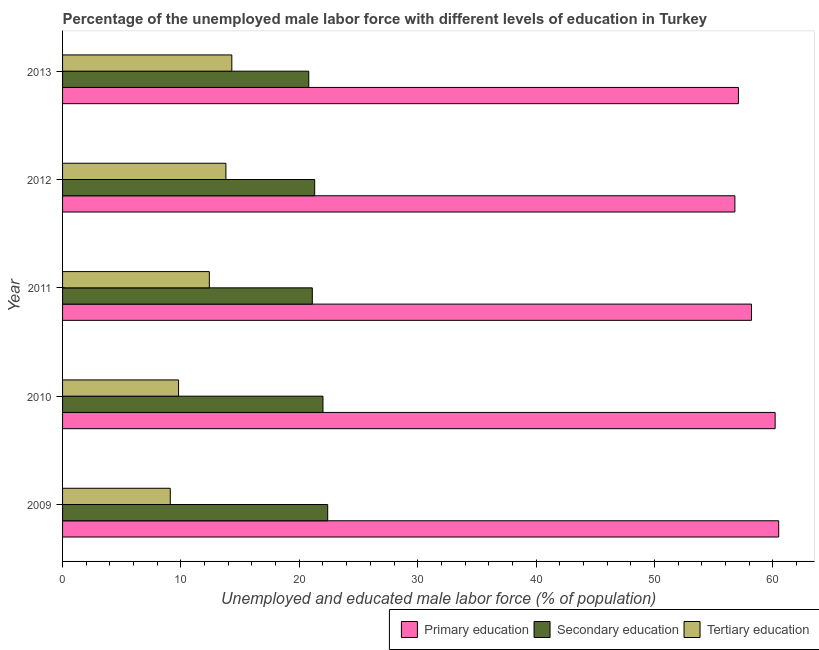Are the number of bars per tick equal to the number of legend labels?
Your response must be concise. Yes. How many bars are there on the 1st tick from the top?
Keep it short and to the point. 3. What is the percentage of male labor force who received tertiary education in 2011?
Provide a short and direct response. 12.4. Across all years, what is the maximum percentage of male labor force who received primary education?
Offer a very short reply. 60.5. Across all years, what is the minimum percentage of male labor force who received tertiary education?
Offer a terse response. 9.1. In which year was the percentage of male labor force who received tertiary education maximum?
Your answer should be compact. 2013. What is the total percentage of male labor force who received secondary education in the graph?
Offer a terse response. 107.6. What is the difference between the percentage of male labor force who received tertiary education in 2012 and the percentage of male labor force who received primary education in 2013?
Ensure brevity in your answer.  -43.3. What is the average percentage of male labor force who received secondary education per year?
Your answer should be compact. 21.52. In the year 2012, what is the difference between the percentage of male labor force who received secondary education and percentage of male labor force who received primary education?
Ensure brevity in your answer.  -35.5. In how many years, is the percentage of male labor force who received primary education greater than 2 %?
Make the answer very short. 5. What is the difference between the highest and the lowest percentage of male labor force who received secondary education?
Your answer should be compact. 1.6. In how many years, is the percentage of male labor force who received secondary education greater than the average percentage of male labor force who received secondary education taken over all years?
Keep it short and to the point. 2. What does the 3rd bar from the bottom in 2011 represents?
Your answer should be compact. Tertiary education. How many bars are there?
Your response must be concise. 15. How many years are there in the graph?
Your answer should be very brief. 5. What is the difference between two consecutive major ticks on the X-axis?
Make the answer very short. 10. Does the graph contain any zero values?
Your answer should be compact. No. Where does the legend appear in the graph?
Offer a very short reply. Bottom right. How are the legend labels stacked?
Your response must be concise. Horizontal. What is the title of the graph?
Make the answer very short. Percentage of the unemployed male labor force with different levels of education in Turkey. Does "Argument" appear as one of the legend labels in the graph?
Your response must be concise. No. What is the label or title of the X-axis?
Offer a very short reply. Unemployed and educated male labor force (% of population). What is the label or title of the Y-axis?
Offer a terse response. Year. What is the Unemployed and educated male labor force (% of population) in Primary education in 2009?
Provide a succinct answer. 60.5. What is the Unemployed and educated male labor force (% of population) of Secondary education in 2009?
Provide a short and direct response. 22.4. What is the Unemployed and educated male labor force (% of population) of Tertiary education in 2009?
Give a very brief answer. 9.1. What is the Unemployed and educated male labor force (% of population) in Primary education in 2010?
Your answer should be very brief. 60.2. What is the Unemployed and educated male labor force (% of population) in Tertiary education in 2010?
Your response must be concise. 9.8. What is the Unemployed and educated male labor force (% of population) of Primary education in 2011?
Your answer should be very brief. 58.2. What is the Unemployed and educated male labor force (% of population) in Secondary education in 2011?
Your answer should be compact. 21.1. What is the Unemployed and educated male labor force (% of population) in Tertiary education in 2011?
Offer a very short reply. 12.4. What is the Unemployed and educated male labor force (% of population) in Primary education in 2012?
Ensure brevity in your answer.  56.8. What is the Unemployed and educated male labor force (% of population) in Secondary education in 2012?
Your response must be concise. 21.3. What is the Unemployed and educated male labor force (% of population) in Tertiary education in 2012?
Keep it short and to the point. 13.8. What is the Unemployed and educated male labor force (% of population) in Primary education in 2013?
Your response must be concise. 57.1. What is the Unemployed and educated male labor force (% of population) in Secondary education in 2013?
Your response must be concise. 20.8. What is the Unemployed and educated male labor force (% of population) in Tertiary education in 2013?
Keep it short and to the point. 14.3. Across all years, what is the maximum Unemployed and educated male labor force (% of population) in Primary education?
Your answer should be compact. 60.5. Across all years, what is the maximum Unemployed and educated male labor force (% of population) in Secondary education?
Give a very brief answer. 22.4. Across all years, what is the maximum Unemployed and educated male labor force (% of population) in Tertiary education?
Your response must be concise. 14.3. Across all years, what is the minimum Unemployed and educated male labor force (% of population) in Primary education?
Give a very brief answer. 56.8. Across all years, what is the minimum Unemployed and educated male labor force (% of population) of Secondary education?
Give a very brief answer. 20.8. Across all years, what is the minimum Unemployed and educated male labor force (% of population) of Tertiary education?
Keep it short and to the point. 9.1. What is the total Unemployed and educated male labor force (% of population) of Primary education in the graph?
Your answer should be very brief. 292.8. What is the total Unemployed and educated male labor force (% of population) of Secondary education in the graph?
Give a very brief answer. 107.6. What is the total Unemployed and educated male labor force (% of population) in Tertiary education in the graph?
Your response must be concise. 59.4. What is the difference between the Unemployed and educated male labor force (% of population) of Primary education in 2009 and that in 2010?
Offer a very short reply. 0.3. What is the difference between the Unemployed and educated male labor force (% of population) of Secondary education in 2009 and that in 2010?
Provide a short and direct response. 0.4. What is the difference between the Unemployed and educated male labor force (% of population) in Primary education in 2009 and that in 2011?
Ensure brevity in your answer.  2.3. What is the difference between the Unemployed and educated male labor force (% of population) in Secondary education in 2009 and that in 2012?
Provide a succinct answer. 1.1. What is the difference between the Unemployed and educated male labor force (% of population) in Primary education in 2009 and that in 2013?
Provide a succinct answer. 3.4. What is the difference between the Unemployed and educated male labor force (% of population) in Secondary education in 2009 and that in 2013?
Make the answer very short. 1.6. What is the difference between the Unemployed and educated male labor force (% of population) of Tertiary education in 2009 and that in 2013?
Offer a terse response. -5.2. What is the difference between the Unemployed and educated male labor force (% of population) in Primary education in 2010 and that in 2011?
Keep it short and to the point. 2. What is the difference between the Unemployed and educated male labor force (% of population) in Secondary education in 2010 and that in 2011?
Provide a succinct answer. 0.9. What is the difference between the Unemployed and educated male labor force (% of population) of Primary education in 2010 and that in 2012?
Provide a short and direct response. 3.4. What is the difference between the Unemployed and educated male labor force (% of population) of Secondary education in 2010 and that in 2012?
Make the answer very short. 0.7. What is the difference between the Unemployed and educated male labor force (% of population) in Tertiary education in 2010 and that in 2012?
Keep it short and to the point. -4. What is the difference between the Unemployed and educated male labor force (% of population) of Secondary education in 2010 and that in 2013?
Provide a short and direct response. 1.2. What is the difference between the Unemployed and educated male labor force (% of population) of Tertiary education in 2010 and that in 2013?
Make the answer very short. -4.5. What is the difference between the Unemployed and educated male labor force (% of population) of Primary education in 2011 and that in 2012?
Keep it short and to the point. 1.4. What is the difference between the Unemployed and educated male labor force (% of population) in Secondary education in 2011 and that in 2012?
Your answer should be very brief. -0.2. What is the difference between the Unemployed and educated male labor force (% of population) in Primary education in 2011 and that in 2013?
Ensure brevity in your answer.  1.1. What is the difference between the Unemployed and educated male labor force (% of population) of Secondary education in 2011 and that in 2013?
Ensure brevity in your answer.  0.3. What is the difference between the Unemployed and educated male labor force (% of population) of Primary education in 2012 and that in 2013?
Offer a very short reply. -0.3. What is the difference between the Unemployed and educated male labor force (% of population) of Secondary education in 2012 and that in 2013?
Your response must be concise. 0.5. What is the difference between the Unemployed and educated male labor force (% of population) in Tertiary education in 2012 and that in 2013?
Give a very brief answer. -0.5. What is the difference between the Unemployed and educated male labor force (% of population) of Primary education in 2009 and the Unemployed and educated male labor force (% of population) of Secondary education in 2010?
Provide a succinct answer. 38.5. What is the difference between the Unemployed and educated male labor force (% of population) of Primary education in 2009 and the Unemployed and educated male labor force (% of population) of Tertiary education in 2010?
Keep it short and to the point. 50.7. What is the difference between the Unemployed and educated male labor force (% of population) of Secondary education in 2009 and the Unemployed and educated male labor force (% of population) of Tertiary education in 2010?
Offer a terse response. 12.6. What is the difference between the Unemployed and educated male labor force (% of population) in Primary education in 2009 and the Unemployed and educated male labor force (% of population) in Secondary education in 2011?
Your answer should be very brief. 39.4. What is the difference between the Unemployed and educated male labor force (% of population) of Primary education in 2009 and the Unemployed and educated male labor force (% of population) of Tertiary education in 2011?
Provide a short and direct response. 48.1. What is the difference between the Unemployed and educated male labor force (% of population) in Secondary education in 2009 and the Unemployed and educated male labor force (% of population) in Tertiary education in 2011?
Make the answer very short. 10. What is the difference between the Unemployed and educated male labor force (% of population) in Primary education in 2009 and the Unemployed and educated male labor force (% of population) in Secondary education in 2012?
Make the answer very short. 39.2. What is the difference between the Unemployed and educated male labor force (% of population) in Primary education in 2009 and the Unemployed and educated male labor force (% of population) in Tertiary education in 2012?
Your answer should be compact. 46.7. What is the difference between the Unemployed and educated male labor force (% of population) in Primary education in 2009 and the Unemployed and educated male labor force (% of population) in Secondary education in 2013?
Your response must be concise. 39.7. What is the difference between the Unemployed and educated male labor force (% of population) of Primary education in 2009 and the Unemployed and educated male labor force (% of population) of Tertiary education in 2013?
Your answer should be very brief. 46.2. What is the difference between the Unemployed and educated male labor force (% of population) of Secondary education in 2009 and the Unemployed and educated male labor force (% of population) of Tertiary education in 2013?
Your response must be concise. 8.1. What is the difference between the Unemployed and educated male labor force (% of population) of Primary education in 2010 and the Unemployed and educated male labor force (% of population) of Secondary education in 2011?
Your answer should be very brief. 39.1. What is the difference between the Unemployed and educated male labor force (% of population) in Primary education in 2010 and the Unemployed and educated male labor force (% of population) in Tertiary education in 2011?
Offer a terse response. 47.8. What is the difference between the Unemployed and educated male labor force (% of population) of Secondary education in 2010 and the Unemployed and educated male labor force (% of population) of Tertiary education in 2011?
Offer a terse response. 9.6. What is the difference between the Unemployed and educated male labor force (% of population) in Primary education in 2010 and the Unemployed and educated male labor force (% of population) in Secondary education in 2012?
Ensure brevity in your answer.  38.9. What is the difference between the Unemployed and educated male labor force (% of population) of Primary education in 2010 and the Unemployed and educated male labor force (% of population) of Tertiary education in 2012?
Your answer should be compact. 46.4. What is the difference between the Unemployed and educated male labor force (% of population) in Secondary education in 2010 and the Unemployed and educated male labor force (% of population) in Tertiary education in 2012?
Make the answer very short. 8.2. What is the difference between the Unemployed and educated male labor force (% of population) in Primary education in 2010 and the Unemployed and educated male labor force (% of population) in Secondary education in 2013?
Ensure brevity in your answer.  39.4. What is the difference between the Unemployed and educated male labor force (% of population) in Primary education in 2010 and the Unemployed and educated male labor force (% of population) in Tertiary education in 2013?
Ensure brevity in your answer.  45.9. What is the difference between the Unemployed and educated male labor force (% of population) in Secondary education in 2010 and the Unemployed and educated male labor force (% of population) in Tertiary education in 2013?
Give a very brief answer. 7.7. What is the difference between the Unemployed and educated male labor force (% of population) of Primary education in 2011 and the Unemployed and educated male labor force (% of population) of Secondary education in 2012?
Offer a terse response. 36.9. What is the difference between the Unemployed and educated male labor force (% of population) in Primary education in 2011 and the Unemployed and educated male labor force (% of population) in Tertiary education in 2012?
Provide a short and direct response. 44.4. What is the difference between the Unemployed and educated male labor force (% of population) of Secondary education in 2011 and the Unemployed and educated male labor force (% of population) of Tertiary education in 2012?
Give a very brief answer. 7.3. What is the difference between the Unemployed and educated male labor force (% of population) of Primary education in 2011 and the Unemployed and educated male labor force (% of population) of Secondary education in 2013?
Give a very brief answer. 37.4. What is the difference between the Unemployed and educated male labor force (% of population) of Primary education in 2011 and the Unemployed and educated male labor force (% of population) of Tertiary education in 2013?
Offer a terse response. 43.9. What is the difference between the Unemployed and educated male labor force (% of population) of Secondary education in 2011 and the Unemployed and educated male labor force (% of population) of Tertiary education in 2013?
Ensure brevity in your answer.  6.8. What is the difference between the Unemployed and educated male labor force (% of population) of Primary education in 2012 and the Unemployed and educated male labor force (% of population) of Tertiary education in 2013?
Offer a very short reply. 42.5. What is the difference between the Unemployed and educated male labor force (% of population) in Secondary education in 2012 and the Unemployed and educated male labor force (% of population) in Tertiary education in 2013?
Offer a terse response. 7. What is the average Unemployed and educated male labor force (% of population) of Primary education per year?
Make the answer very short. 58.56. What is the average Unemployed and educated male labor force (% of population) of Secondary education per year?
Give a very brief answer. 21.52. What is the average Unemployed and educated male labor force (% of population) in Tertiary education per year?
Provide a short and direct response. 11.88. In the year 2009, what is the difference between the Unemployed and educated male labor force (% of population) of Primary education and Unemployed and educated male labor force (% of population) of Secondary education?
Ensure brevity in your answer.  38.1. In the year 2009, what is the difference between the Unemployed and educated male labor force (% of population) of Primary education and Unemployed and educated male labor force (% of population) of Tertiary education?
Provide a succinct answer. 51.4. In the year 2009, what is the difference between the Unemployed and educated male labor force (% of population) of Secondary education and Unemployed and educated male labor force (% of population) of Tertiary education?
Your response must be concise. 13.3. In the year 2010, what is the difference between the Unemployed and educated male labor force (% of population) of Primary education and Unemployed and educated male labor force (% of population) of Secondary education?
Your response must be concise. 38.2. In the year 2010, what is the difference between the Unemployed and educated male labor force (% of population) in Primary education and Unemployed and educated male labor force (% of population) in Tertiary education?
Provide a succinct answer. 50.4. In the year 2010, what is the difference between the Unemployed and educated male labor force (% of population) in Secondary education and Unemployed and educated male labor force (% of population) in Tertiary education?
Provide a short and direct response. 12.2. In the year 2011, what is the difference between the Unemployed and educated male labor force (% of population) in Primary education and Unemployed and educated male labor force (% of population) in Secondary education?
Provide a succinct answer. 37.1. In the year 2011, what is the difference between the Unemployed and educated male labor force (% of population) of Primary education and Unemployed and educated male labor force (% of population) of Tertiary education?
Your answer should be very brief. 45.8. In the year 2011, what is the difference between the Unemployed and educated male labor force (% of population) of Secondary education and Unemployed and educated male labor force (% of population) of Tertiary education?
Your answer should be very brief. 8.7. In the year 2012, what is the difference between the Unemployed and educated male labor force (% of population) in Primary education and Unemployed and educated male labor force (% of population) in Secondary education?
Make the answer very short. 35.5. In the year 2012, what is the difference between the Unemployed and educated male labor force (% of population) in Secondary education and Unemployed and educated male labor force (% of population) in Tertiary education?
Make the answer very short. 7.5. In the year 2013, what is the difference between the Unemployed and educated male labor force (% of population) in Primary education and Unemployed and educated male labor force (% of population) in Secondary education?
Ensure brevity in your answer.  36.3. In the year 2013, what is the difference between the Unemployed and educated male labor force (% of population) of Primary education and Unemployed and educated male labor force (% of population) of Tertiary education?
Offer a terse response. 42.8. In the year 2013, what is the difference between the Unemployed and educated male labor force (% of population) of Secondary education and Unemployed and educated male labor force (% of population) of Tertiary education?
Offer a terse response. 6.5. What is the ratio of the Unemployed and educated male labor force (% of population) in Primary education in 2009 to that in 2010?
Offer a very short reply. 1. What is the ratio of the Unemployed and educated male labor force (% of population) in Secondary education in 2009 to that in 2010?
Offer a terse response. 1.02. What is the ratio of the Unemployed and educated male labor force (% of population) in Tertiary education in 2009 to that in 2010?
Offer a terse response. 0.93. What is the ratio of the Unemployed and educated male labor force (% of population) of Primary education in 2009 to that in 2011?
Your response must be concise. 1.04. What is the ratio of the Unemployed and educated male labor force (% of population) of Secondary education in 2009 to that in 2011?
Offer a terse response. 1.06. What is the ratio of the Unemployed and educated male labor force (% of population) in Tertiary education in 2009 to that in 2011?
Keep it short and to the point. 0.73. What is the ratio of the Unemployed and educated male labor force (% of population) of Primary education in 2009 to that in 2012?
Offer a very short reply. 1.07. What is the ratio of the Unemployed and educated male labor force (% of population) in Secondary education in 2009 to that in 2012?
Your response must be concise. 1.05. What is the ratio of the Unemployed and educated male labor force (% of population) of Tertiary education in 2009 to that in 2012?
Your answer should be very brief. 0.66. What is the ratio of the Unemployed and educated male labor force (% of population) in Primary education in 2009 to that in 2013?
Make the answer very short. 1.06. What is the ratio of the Unemployed and educated male labor force (% of population) of Secondary education in 2009 to that in 2013?
Make the answer very short. 1.08. What is the ratio of the Unemployed and educated male labor force (% of population) in Tertiary education in 2009 to that in 2013?
Provide a short and direct response. 0.64. What is the ratio of the Unemployed and educated male labor force (% of population) in Primary education in 2010 to that in 2011?
Offer a terse response. 1.03. What is the ratio of the Unemployed and educated male labor force (% of population) in Secondary education in 2010 to that in 2011?
Offer a very short reply. 1.04. What is the ratio of the Unemployed and educated male labor force (% of population) of Tertiary education in 2010 to that in 2011?
Provide a short and direct response. 0.79. What is the ratio of the Unemployed and educated male labor force (% of population) in Primary education in 2010 to that in 2012?
Ensure brevity in your answer.  1.06. What is the ratio of the Unemployed and educated male labor force (% of population) in Secondary education in 2010 to that in 2012?
Your answer should be very brief. 1.03. What is the ratio of the Unemployed and educated male labor force (% of population) in Tertiary education in 2010 to that in 2012?
Offer a terse response. 0.71. What is the ratio of the Unemployed and educated male labor force (% of population) in Primary education in 2010 to that in 2013?
Ensure brevity in your answer.  1.05. What is the ratio of the Unemployed and educated male labor force (% of population) in Secondary education in 2010 to that in 2013?
Offer a terse response. 1.06. What is the ratio of the Unemployed and educated male labor force (% of population) of Tertiary education in 2010 to that in 2013?
Give a very brief answer. 0.69. What is the ratio of the Unemployed and educated male labor force (% of population) of Primary education in 2011 to that in 2012?
Make the answer very short. 1.02. What is the ratio of the Unemployed and educated male labor force (% of population) of Secondary education in 2011 to that in 2012?
Provide a succinct answer. 0.99. What is the ratio of the Unemployed and educated male labor force (% of population) of Tertiary education in 2011 to that in 2012?
Offer a terse response. 0.9. What is the ratio of the Unemployed and educated male labor force (% of population) of Primary education in 2011 to that in 2013?
Provide a short and direct response. 1.02. What is the ratio of the Unemployed and educated male labor force (% of population) of Secondary education in 2011 to that in 2013?
Provide a succinct answer. 1.01. What is the ratio of the Unemployed and educated male labor force (% of population) in Tertiary education in 2011 to that in 2013?
Make the answer very short. 0.87. What is the ratio of the Unemployed and educated male labor force (% of population) of Primary education in 2012 to that in 2013?
Ensure brevity in your answer.  0.99. What is the ratio of the Unemployed and educated male labor force (% of population) in Secondary education in 2012 to that in 2013?
Offer a terse response. 1.02. What is the ratio of the Unemployed and educated male labor force (% of population) of Tertiary education in 2012 to that in 2013?
Keep it short and to the point. 0.96. What is the difference between the highest and the second highest Unemployed and educated male labor force (% of population) of Secondary education?
Offer a very short reply. 0.4. What is the difference between the highest and the lowest Unemployed and educated male labor force (% of population) in Tertiary education?
Your answer should be compact. 5.2. 